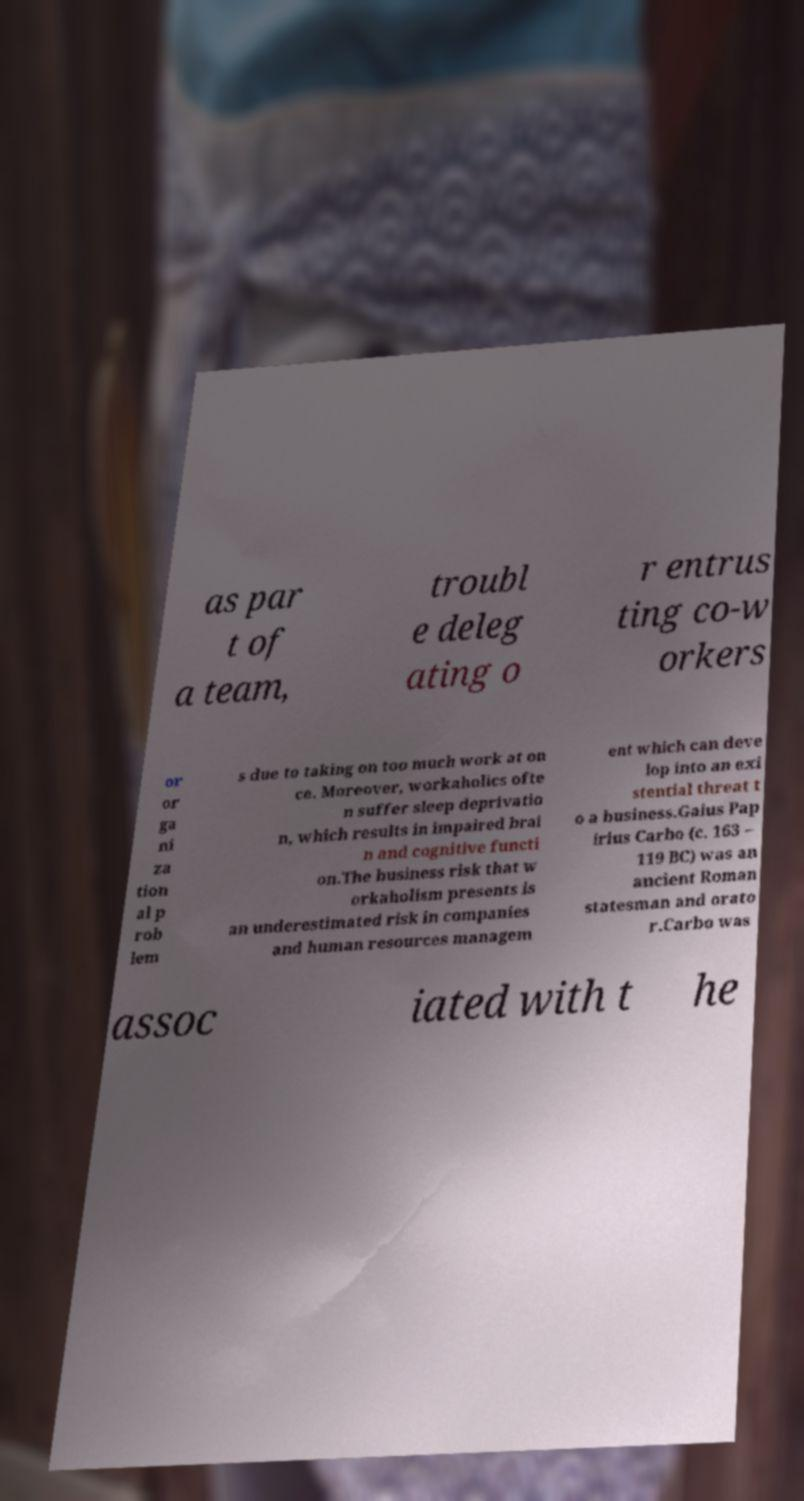Could you assist in decoding the text presented in this image and type it out clearly? as par t of a team, troubl e deleg ating o r entrus ting co-w orkers or or ga ni za tion al p rob lem s due to taking on too much work at on ce. Moreover, workaholics ofte n suffer sleep deprivatio n, which results in impaired brai n and cognitive functi on.The business risk that w orkaholism presents is an underestimated risk in companies and human resources managem ent which can deve lop into an exi stential threat t o a business.Gaius Pap irius Carbo (c. 163 – 119 BC) was an ancient Roman statesman and orato r.Carbo was assoc iated with t he 